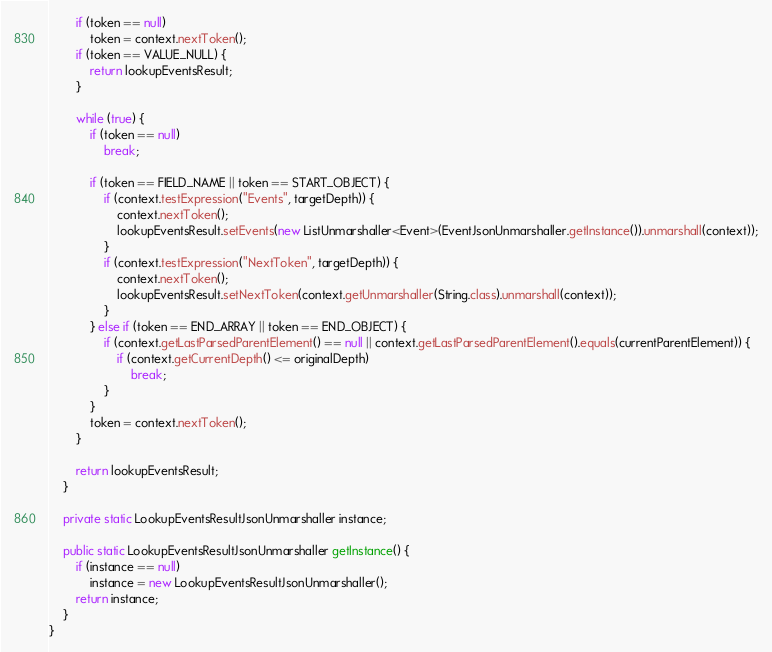<code> <loc_0><loc_0><loc_500><loc_500><_Java_>        if (token == null)
            token = context.nextToken();
        if (token == VALUE_NULL) {
            return lookupEventsResult;
        }

        while (true) {
            if (token == null)
                break;

            if (token == FIELD_NAME || token == START_OBJECT) {
                if (context.testExpression("Events", targetDepth)) {
                    context.nextToken();
                    lookupEventsResult.setEvents(new ListUnmarshaller<Event>(EventJsonUnmarshaller.getInstance()).unmarshall(context));
                }
                if (context.testExpression("NextToken", targetDepth)) {
                    context.nextToken();
                    lookupEventsResult.setNextToken(context.getUnmarshaller(String.class).unmarshall(context));
                }
            } else if (token == END_ARRAY || token == END_OBJECT) {
                if (context.getLastParsedParentElement() == null || context.getLastParsedParentElement().equals(currentParentElement)) {
                    if (context.getCurrentDepth() <= originalDepth)
                        break;
                }
            }
            token = context.nextToken();
        }

        return lookupEventsResult;
    }

    private static LookupEventsResultJsonUnmarshaller instance;

    public static LookupEventsResultJsonUnmarshaller getInstance() {
        if (instance == null)
            instance = new LookupEventsResultJsonUnmarshaller();
        return instance;
    }
}
</code> 